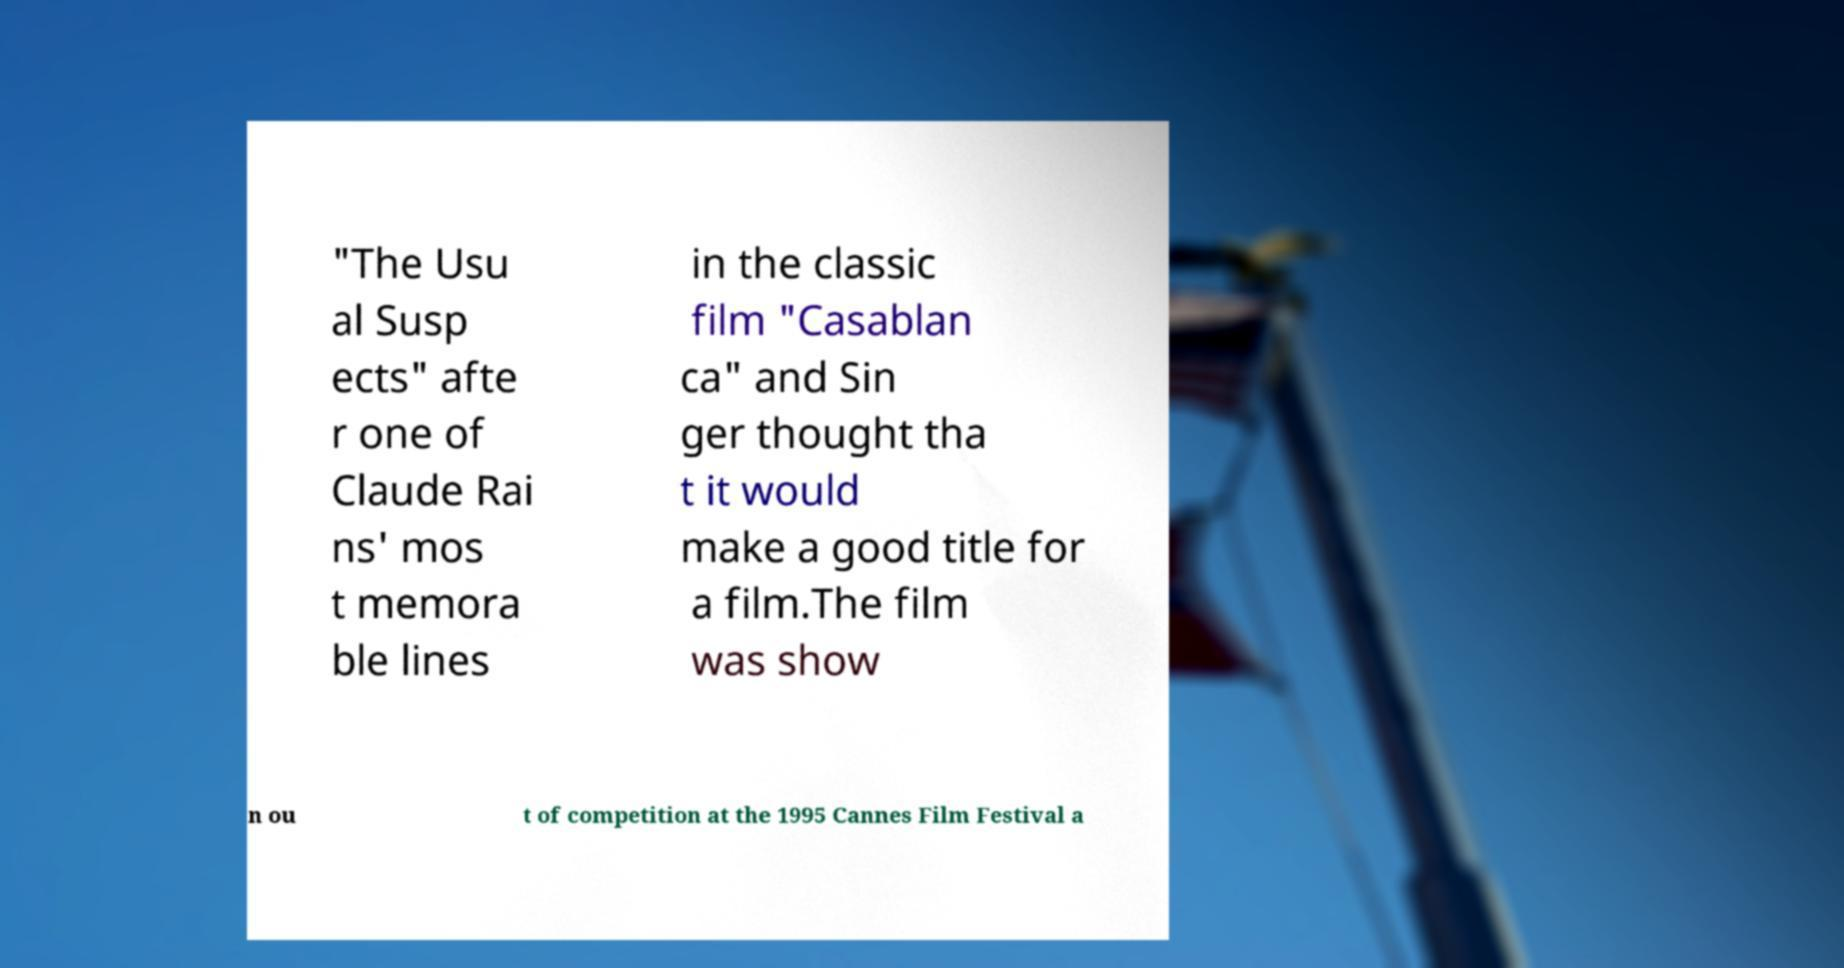I need the written content from this picture converted into text. Can you do that? "The Usu al Susp ects" afte r one of Claude Rai ns' mos t memora ble lines in the classic film "Casablan ca" and Sin ger thought tha t it would make a good title for a film.The film was show n ou t of competition at the 1995 Cannes Film Festival a 